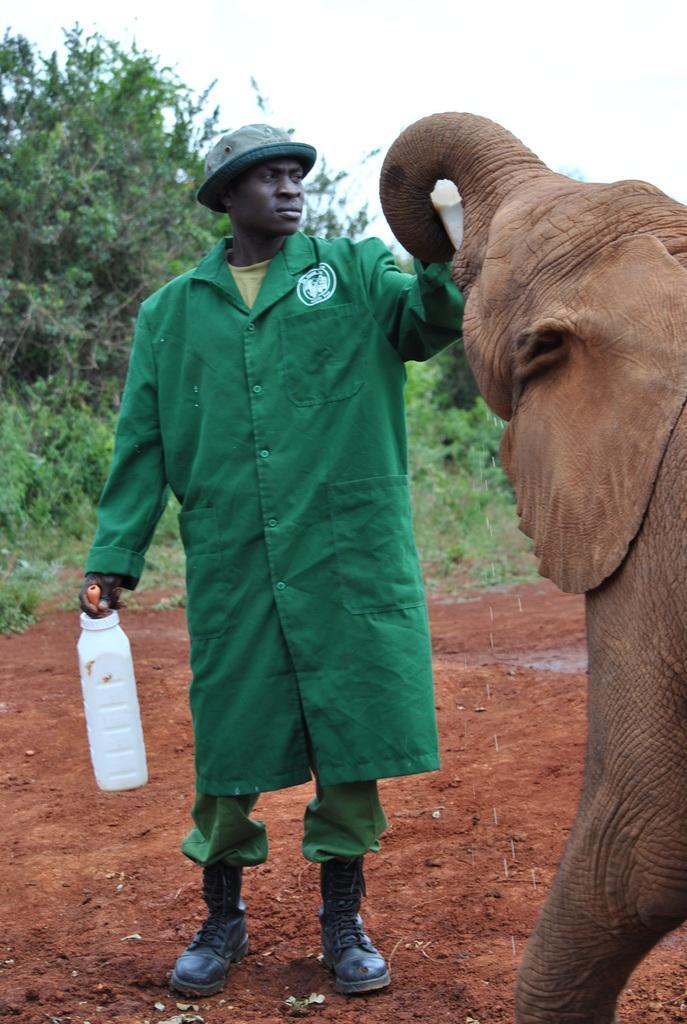How would you summarize this image in a sentence or two? In this picture we can see a man standing and holding a bottle, on the right side there is an elephant, a man wore a cap and shoes, in the background we can see trees, there is sky at the top of the picture. 